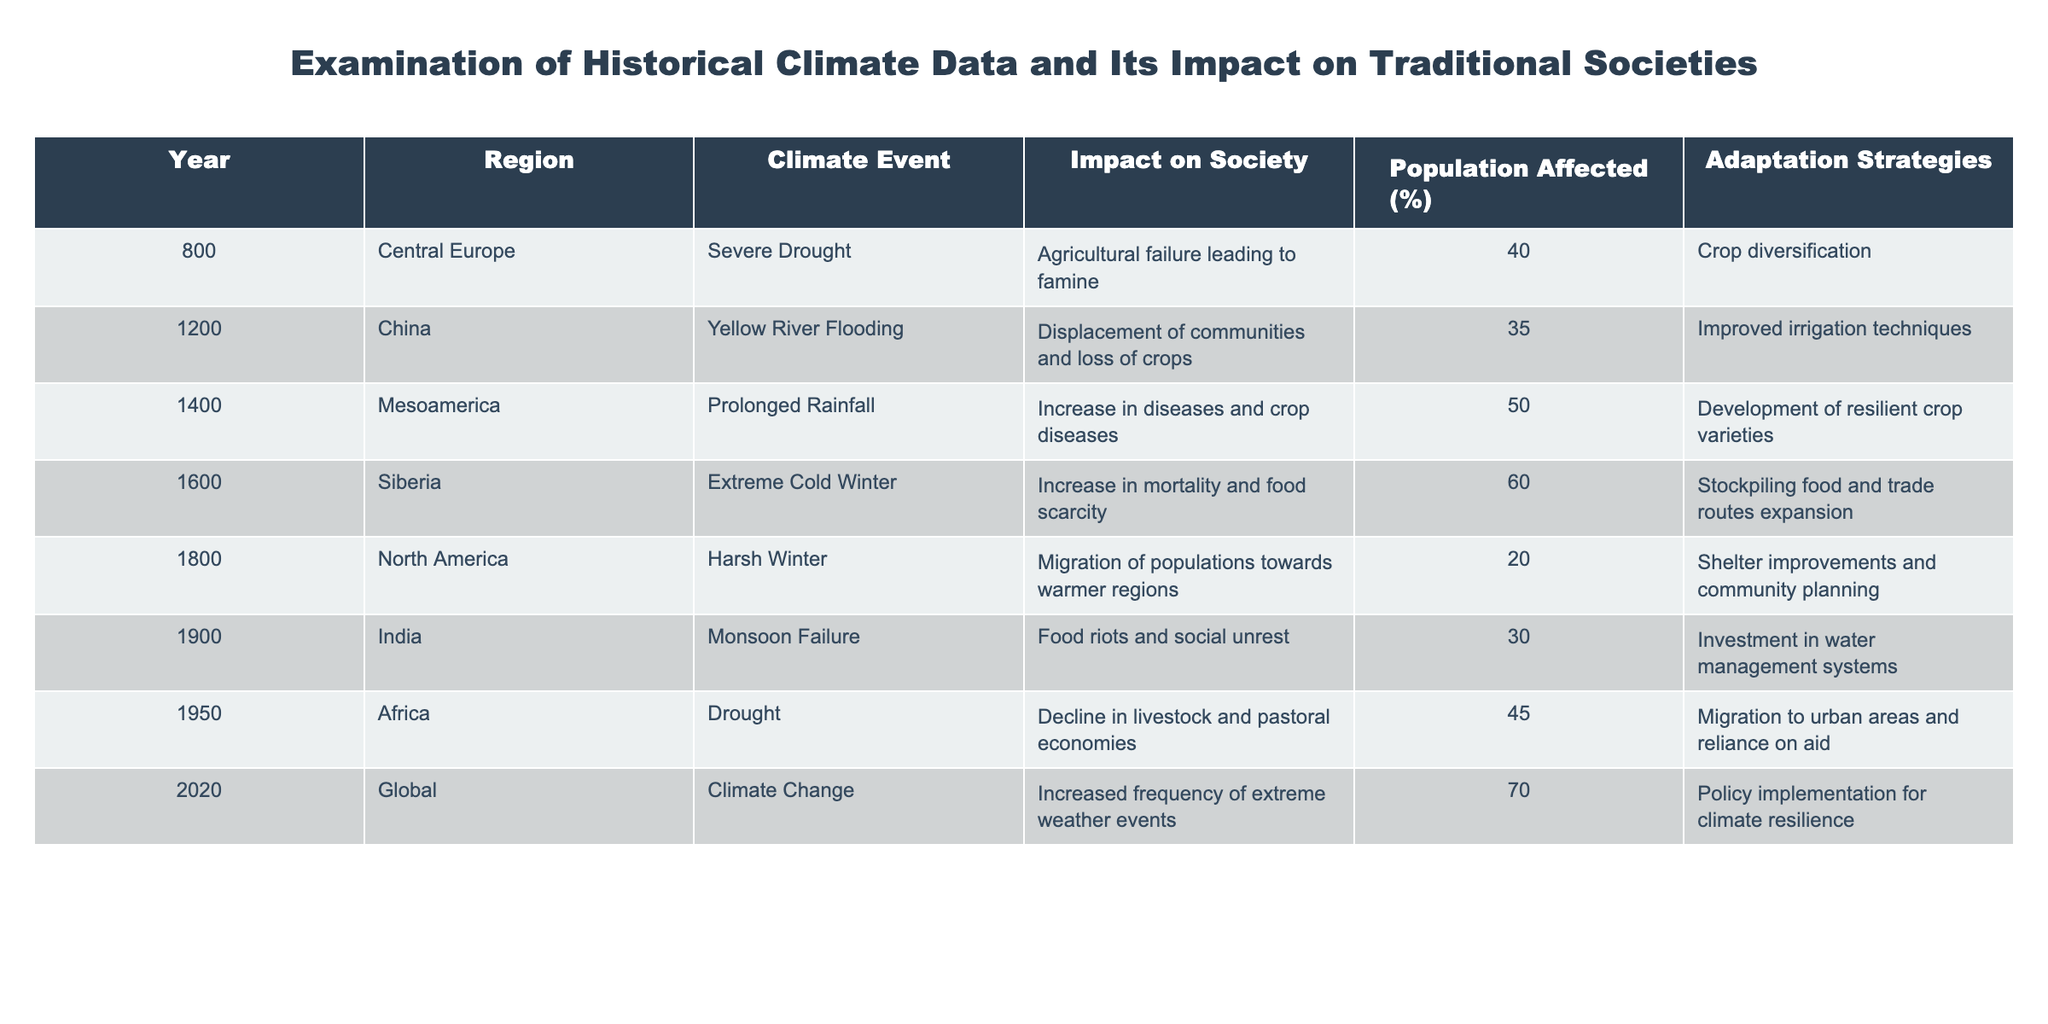What was the population percentage affected by the severe drought in Central Europe in the year 800? The table indicates that the population affected by the severe drought in Central Europe in 800 was 40%. This information is directly available in the row corresponding to that year.
Answer: 40% Which region experienced flooding in the year 1200 and what was its impact on society? According to the table, China experienced flooding in the year 1200, resulting in displacement of communities and loss of crops. This is clearly stated in the respective row for that year.
Answer: Flooding in China; displacement of communities and loss of crops What are the adaptation strategies documented for the extreme cold winter in Siberia in 1600? The table shows that the adaptation strategies for the extreme cold winter in Siberia in the year 1600 included stockpiling food and expanding trade routes. This information is directly derived from the relevant row in the table.
Answer: Stockpiling food and trade routes expansion What is the average percentage of the population affected by climate events from the years 800 to 1800? To find the average, we sum the affected percentages for the relevant years: 40 (800) + 35 (1200) + 50 (1400) + 60 (1600) + 20 (1800) = 205. There are 5 data points, thus the average is 205/5 = 41.
Answer: 41 Did the climate event in 1900 in India result in food riots? The table indicates that the monsoon failure in India in 1900 led to food riots and social unrest. Therefore, the statement is true based on the information in the table.
Answer: Yes Which climate event had the highest percentage of population affected and what was that percentage? Reviewing the table, the climate event in 2020 from the Global category caused the highest percentage of population affected at 70%. This is confirmed by examining the relevant row.
Answer: 70% How many historical climate events, according to the table, led to a migration of populations to other regions? There are three events leading to migration: the harsh winter in North America in 1800, the drought in Africa in 1950, and the climate change impact in 2020. By counting these events, we get a total of three.
Answer: 3 Which two regions had their societies affected by disease and what were the climate events associated with them? Mesoamerica had prolonged rainfall leading to increased diseases, and the other is not explicitly in the dataset; therefore, we only have one region with this impact directly from the table, and there are no double occurrences of disease impact events.
Answer: Mesoamerica (prolonged rainfall) only What adaptation strategy is common to both the severe drought in Africa in 1950 and the climate change event in 2020? Both events saw adaptation strategies that involved migration, with Africa seeing a migration to urban areas and reliance on aid in 1950, and climate resilience policies in 2020 having an indirect implication of community movements for adaptation. Comparing the strategies, migration is a common theme.
Answer: Migration 